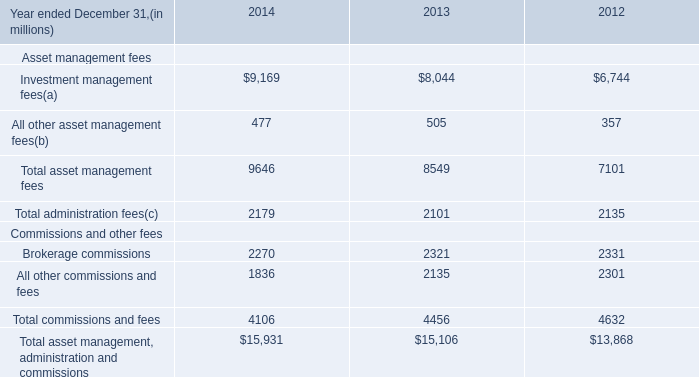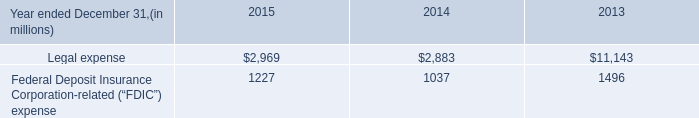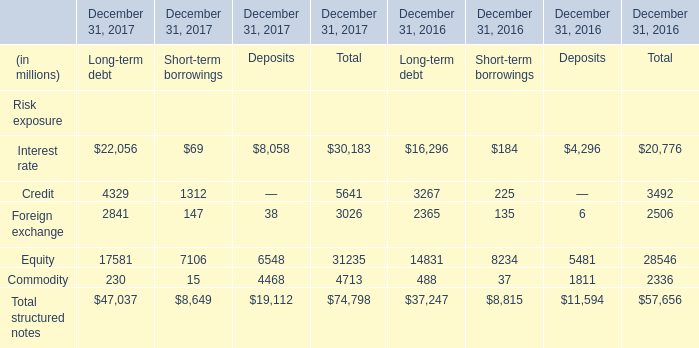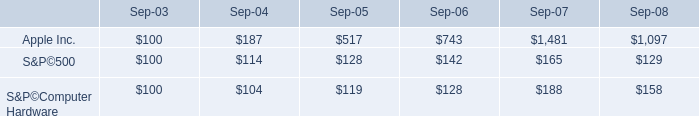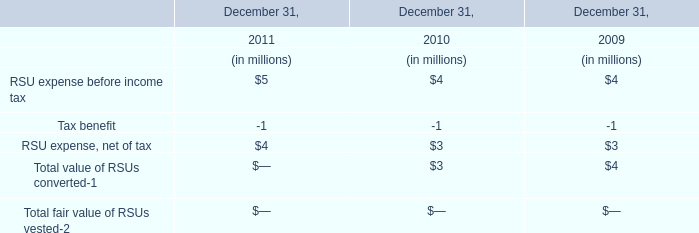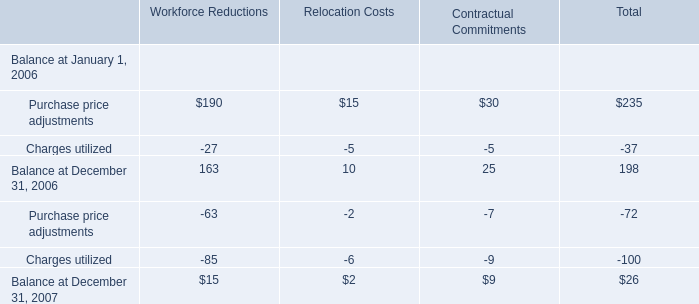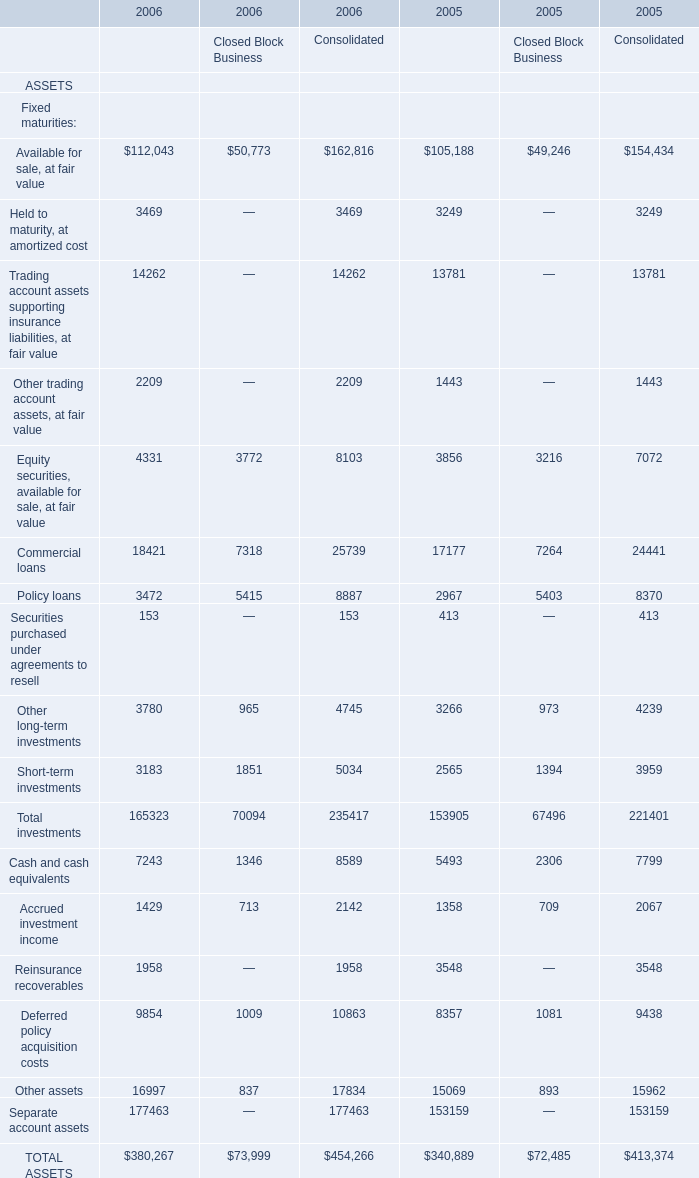What is the average amount of Equity of December 31, 2017 Deposits, and TOTAL ASSETS of 2006 Financial Services Businesses ? 
Computations: ((6548.0 + 380267.0) / 2)
Answer: 193407.5. 